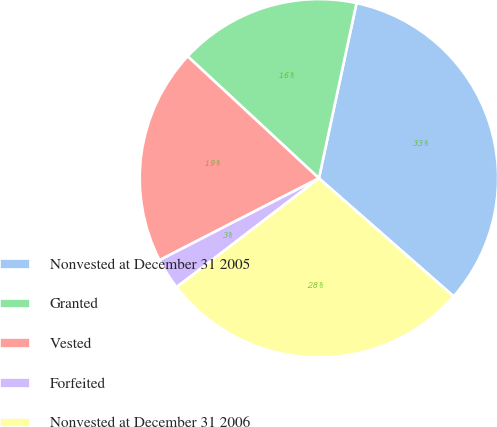Convert chart to OTSL. <chart><loc_0><loc_0><loc_500><loc_500><pie_chart><fcel>Nonvested at December 31 2005<fcel>Granted<fcel>Vested<fcel>Forfeited<fcel>Nonvested at December 31 2006<nl><fcel>33.09%<fcel>16.45%<fcel>19.47%<fcel>2.84%<fcel>28.15%<nl></chart> 